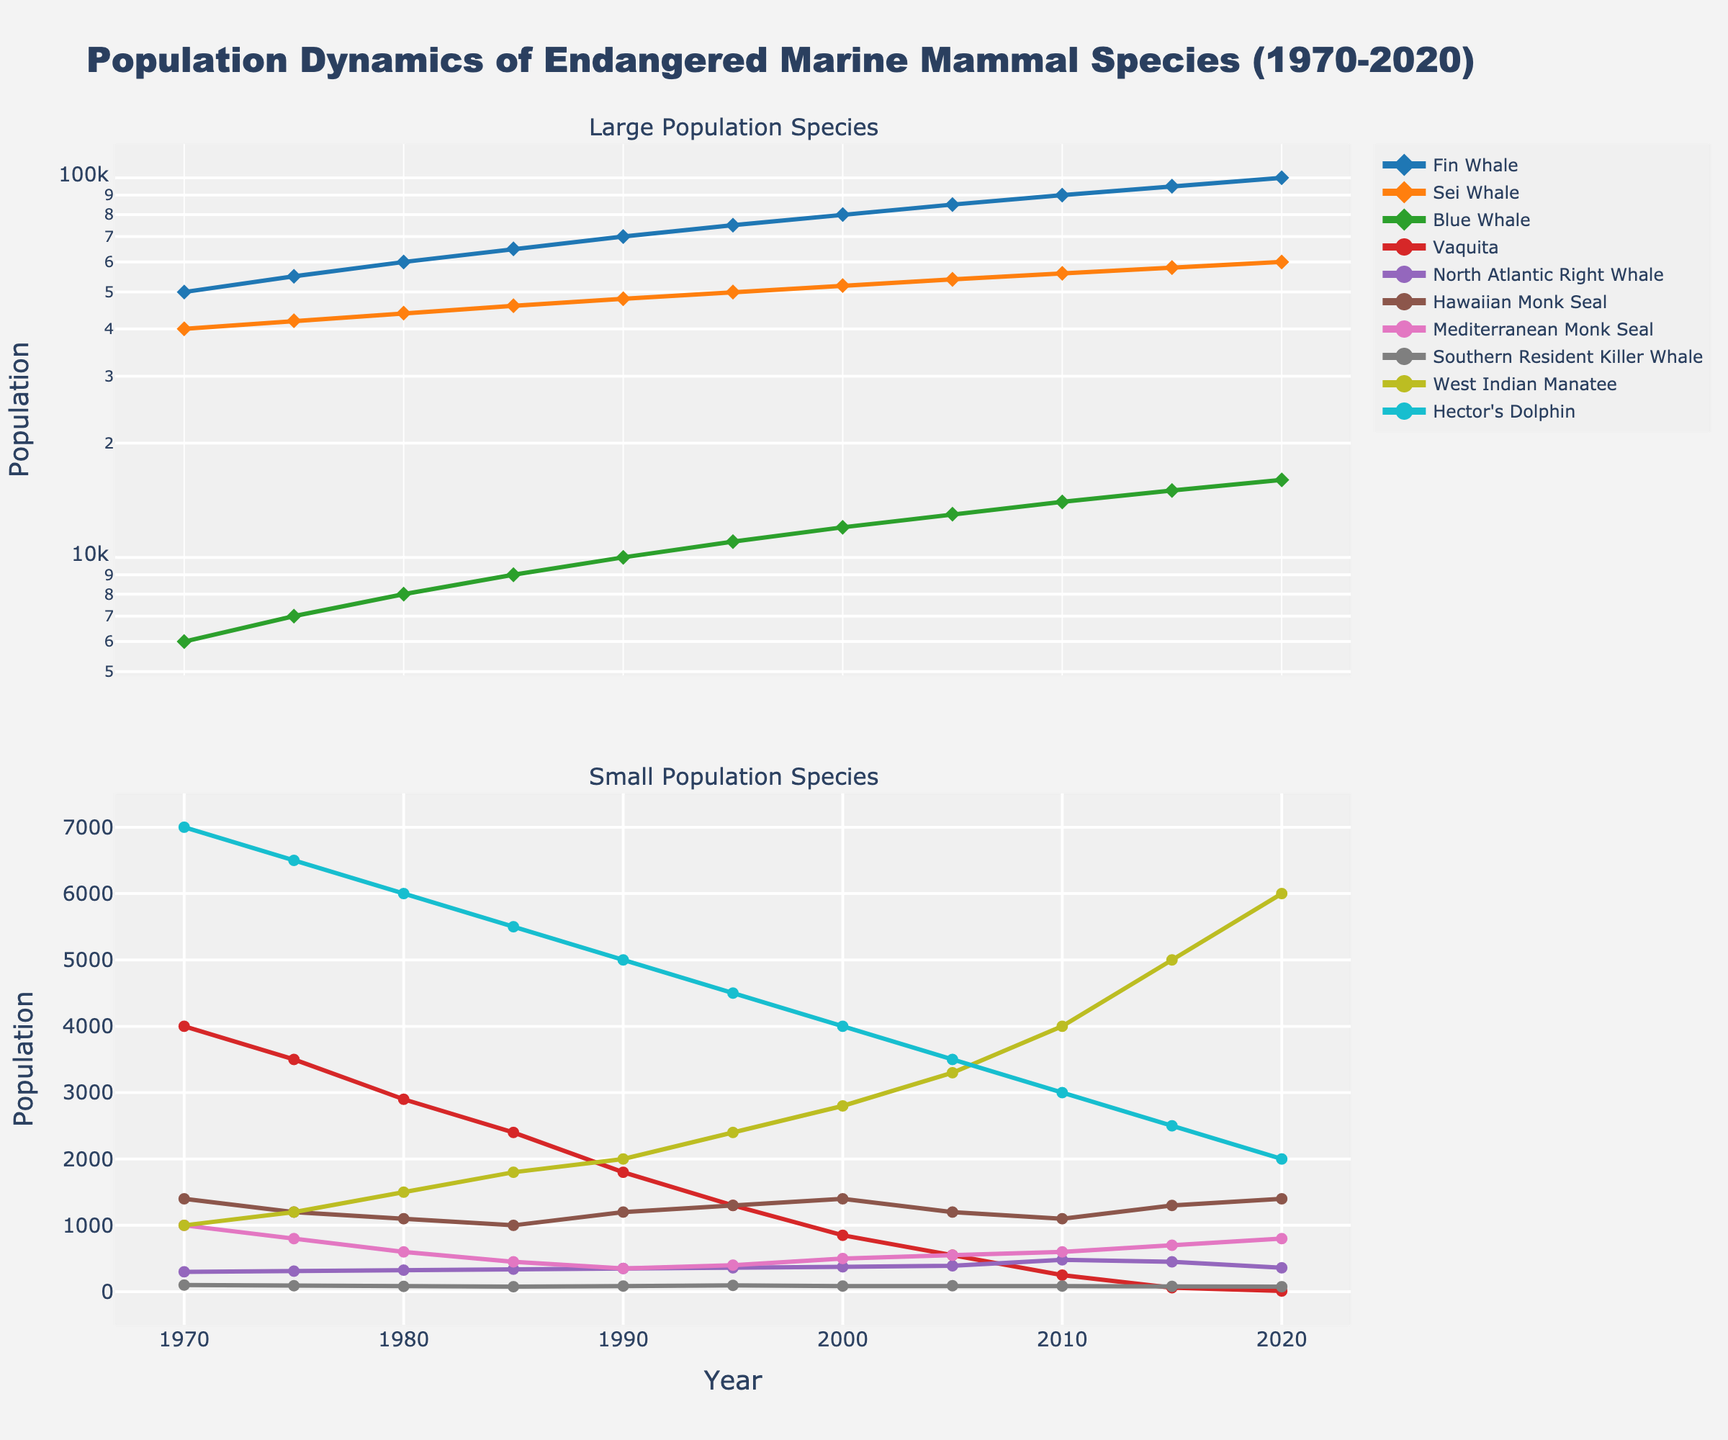What's the population trend of the Vaquita over the last 50 years? The Vaquita population steadily declines over the 50-year period. Starting from 4000 in 1970, it decreases continuously to just 10 in 2020, indicating a severe decline in numbers.
Answer: Severe decline Which species had a population increase from 2010 to 2020 among the small population species? Among the small population species (excluding Fin Whale, Sei Whale, and Blue Whale), the Hawaiian Monk Seal and Mediterranean Monk Seal show an increase in population from 2010 to 2020. Hawaiian Monk Seal increases from 1100 to 1400, and Mediterranean Monk Seal increases from 600 to 800.
Answer: Hawaiian Monk Seal, Mediterranean Monk Seal Between the North Atlantic Right Whale and Southern Resident Killer Whale, which species had a higher population in 2000 and by how much? In 2000, the North Atlantic Right Whale had 375 individuals, while the Southern Resident Killer Whale had 85. To find the difference: 375 - 85 = 290. The North Atlantic Right Whale had 290 more individuals.
Answer: North Atlantic Right Whale by 290 How does the population of the Blue Whale compare to that of the Sei Whale in 2020? In 2020, the population of the Blue Whale is 16000, while the population of the Sei Whale is 60000. Comparing these numbers, the Sei Whale's population is considerably larger than that of the Blue Whale.
Answer: Sei Whale is larger What is the ratio of the Fin Whale population to that of the Hector's Dolphin population in 1980? In 1980, the Fin Whale population is 60000, and Hector's Dolphin population is 6000. The ratio is calculated as 60000 / 6000 = 10.
Answer: 10 Identify the species with the smallest population in 2020. By examining the populations in 2020, the Vaquita has the smallest population of just 10 individuals.
Answer: Vaquita For the Mediterranean Monk Seal, what is the percentage increase in population from 1990 to 2020? The population in 1990 is 350, and in 2020 it is 800. The percentage increase is calculated by \(\frac{800 - 350}{350} \times 100\% = \frac{450}{350} \times 100\% \approx 128.57\%\).
Answer: ~128.57% Of the large population species, which one experienced the highest increase in population from 1970 to 2020? Comparing the increase in population from 1970 to 2020 for Fin Whale (50000 to 100000), Sei Whale (40000 to 60000), and Blue Whale (6000 to 16000): Fin Whale increased by 50000, Sei Whale by 20000, and Blue Whale by 10000. The Fin Whale shows the highest increase.
Answer: Fin Whale What was the population of the West Indian Manatee in 1990 compared to 1985? In 1985, the population of the West Indian Manatee was 1800, which increased to 2000 in 1990. Comparing these, it grew by 200 individuals from 1985 to 1990.
Answer: 200 more Which species shows a decreasing trend in the second plot, and what was its population in 2010? The Southern Resident Killer Whale shows a decreasing trend in the second plot. Its population in 2010 was 85 individuals.
Answer: Southern Resident Killer Whale, 85 